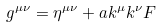<formula> <loc_0><loc_0><loc_500><loc_500>g ^ { \mu \nu } = \eta ^ { \mu \nu } + a k ^ { \mu } k ^ { \nu } F</formula> 